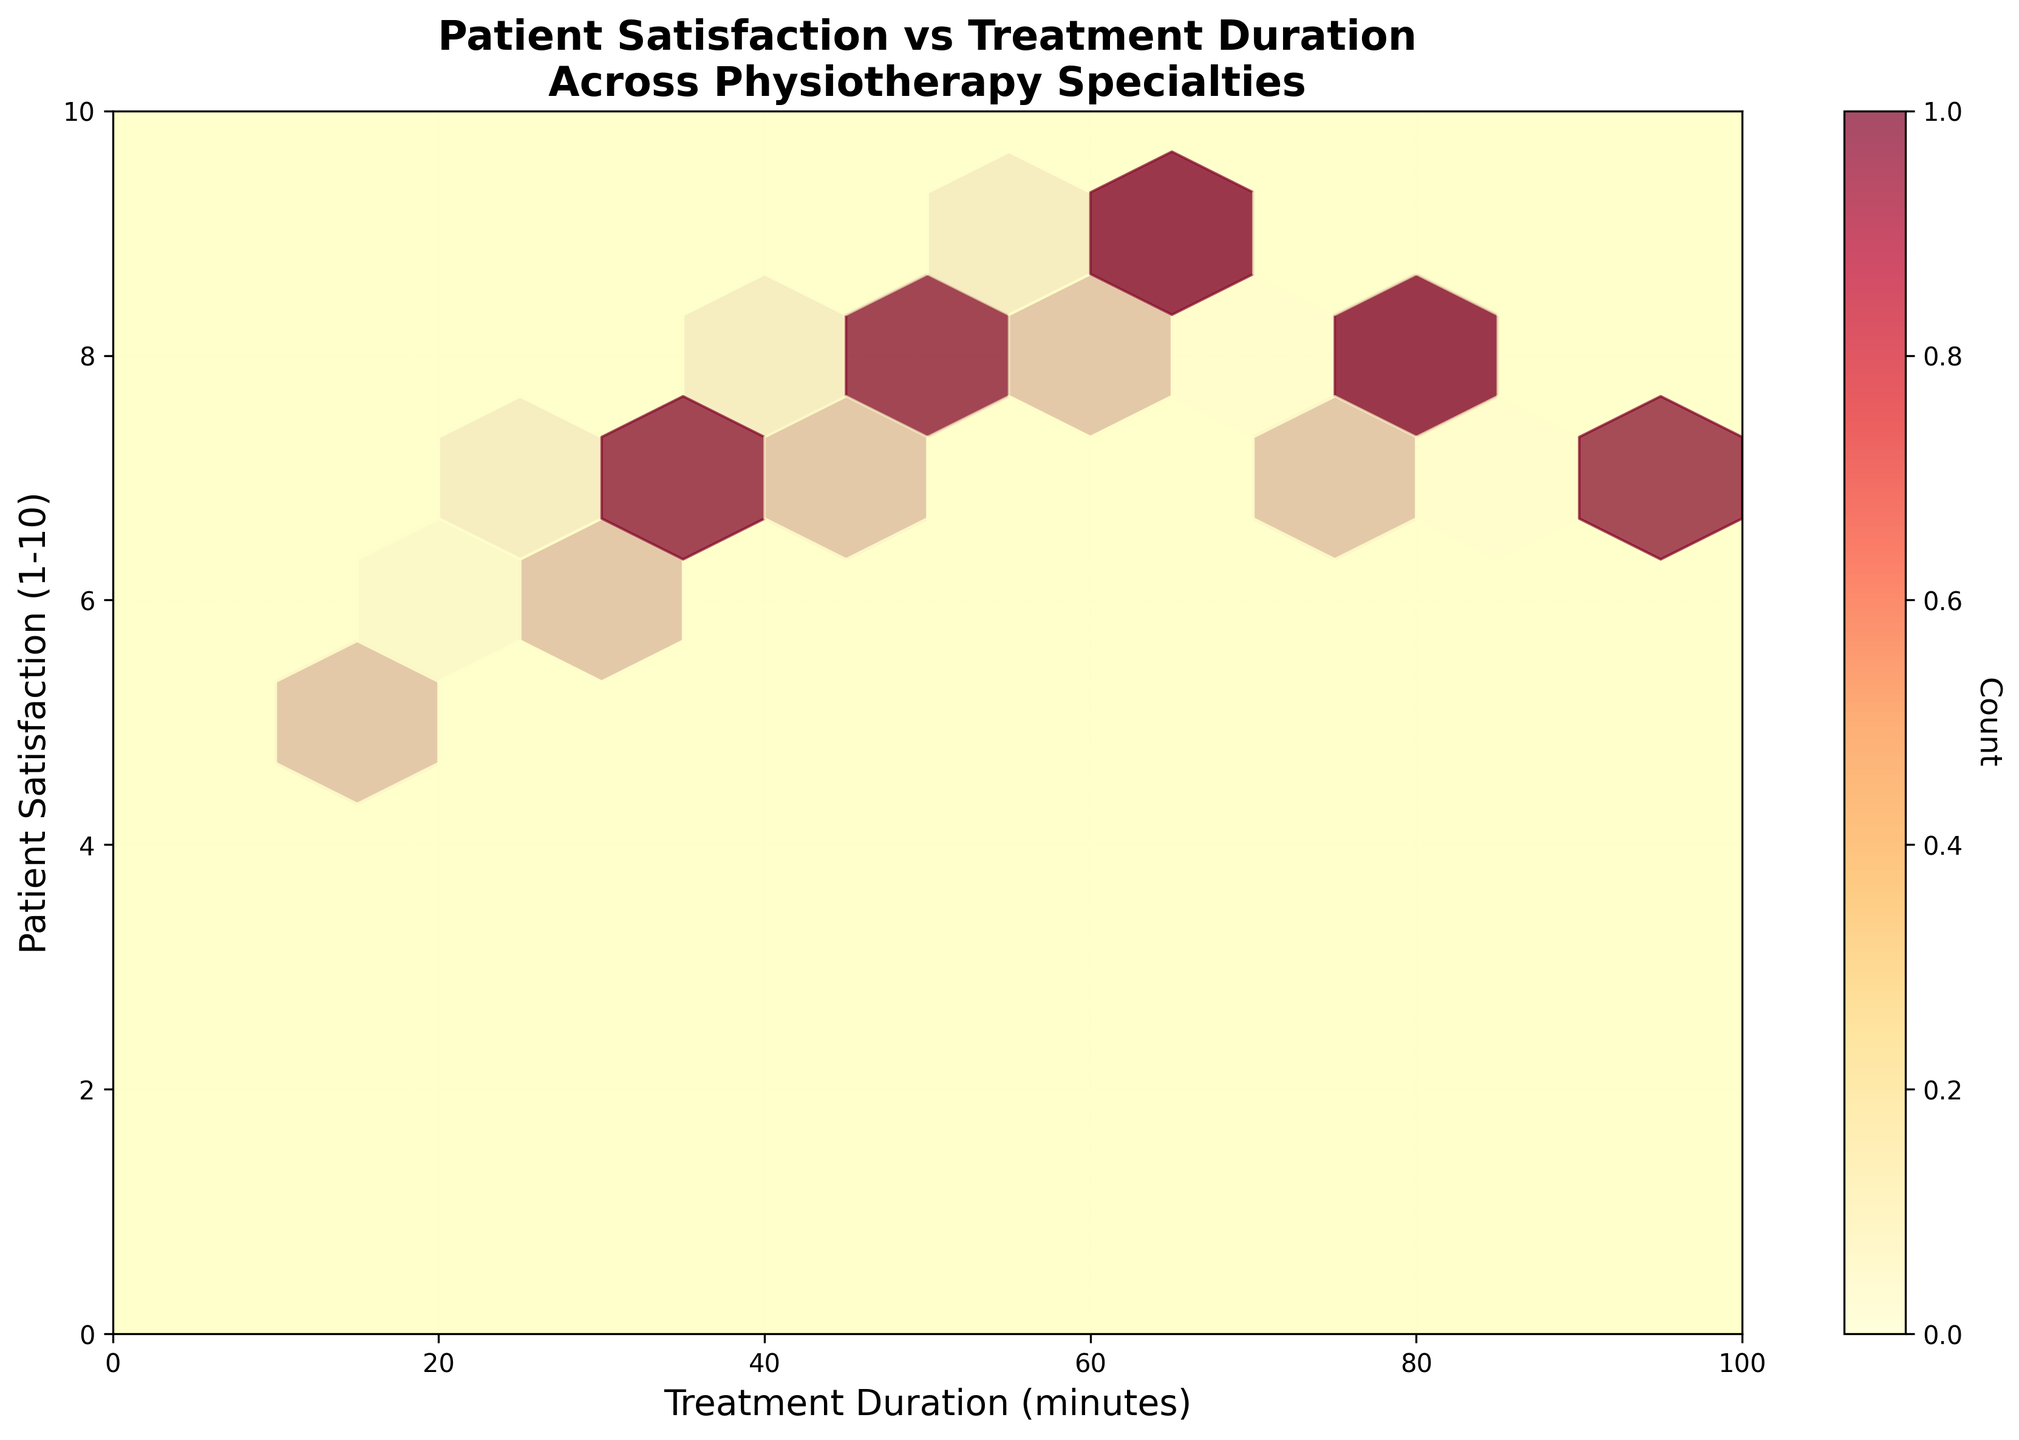What's the title of the plot? The title of the plot is displayed at the top of the figure and is usually in a bold font to stand out.
Answer: Patient Satisfaction vs Treatment Duration Across Physiotherapy Specialties What units are used for the x-axis? The x-axis represents the treatment duration in minutes, as indicated by the axis label and the numerical tick marks.
Answer: Minutes Which specialty has treatment durations ranging from approximately 15 to 75 minutes? By matching the specialty names to the treatment duration range on the x-axis, Geriatrics has treatment durations that range from 15 to 75 minutes.
Answer: Geriatrics What is the color indicating the highest density of data points? Consulting the color bar beside the hexbin plot that represents the count or density of data points, the color indicating the highest density is a deep red.
Answer: Deep Red Which specialty shows the highest patient satisfaction ratings around 55 minutes of treatment duration? Observing the hexbin plot, the highest satisfaction ratings around 55 minutes on the x-axis are indicated by the "Sports Rehabilitation" specialty.
Answer: Sports Rehabilitation Is there a specialty that consistently has high satisfaction ratings (8 or above) for all treatment durations? Analyzing the entire plot for continuous high satisfaction ratings, Sports Rehabilitation consistently shows satisfaction ratings of 8 or above for all its treatment durations.
Answer: Yes, Sports Rehabilitation Which specialty typically has the lowest patient satisfaction for shortest treatment durations? Examining the data points and their satisfaction ratings for shortest durations (around 15-20 minutes), Geriatrics typically shows the lowest patient satisfaction.
Answer: Geriatrics What is the patient satisfaction rating for Orthopedics with a treatment duration of around 60 minutes? Observing the plot closely at the intersection for Orthopedics around 60 minutes on the x-axis, the patient satisfaction rating is 9.
Answer: 9 How does the satisfaction rating trend compare between Neurology and Pediatrics? By comparing the data points and their trends, both Neurology and Pediatrics show increasing satisfaction ratings with increasing treatment durations, though Pediatrics has more variability at longer durations.
Answer: Both increase but Pediatrics has more variability Are the treatment durations of 50 minutes more densely populated for any particular specialty? By consulting the plot, it's evident that treatment durations around 50 minutes show high density for Pediatrics and Neurology, indicated by the darker color shades in those regions.
Answer: Pediatrics and Neurology 